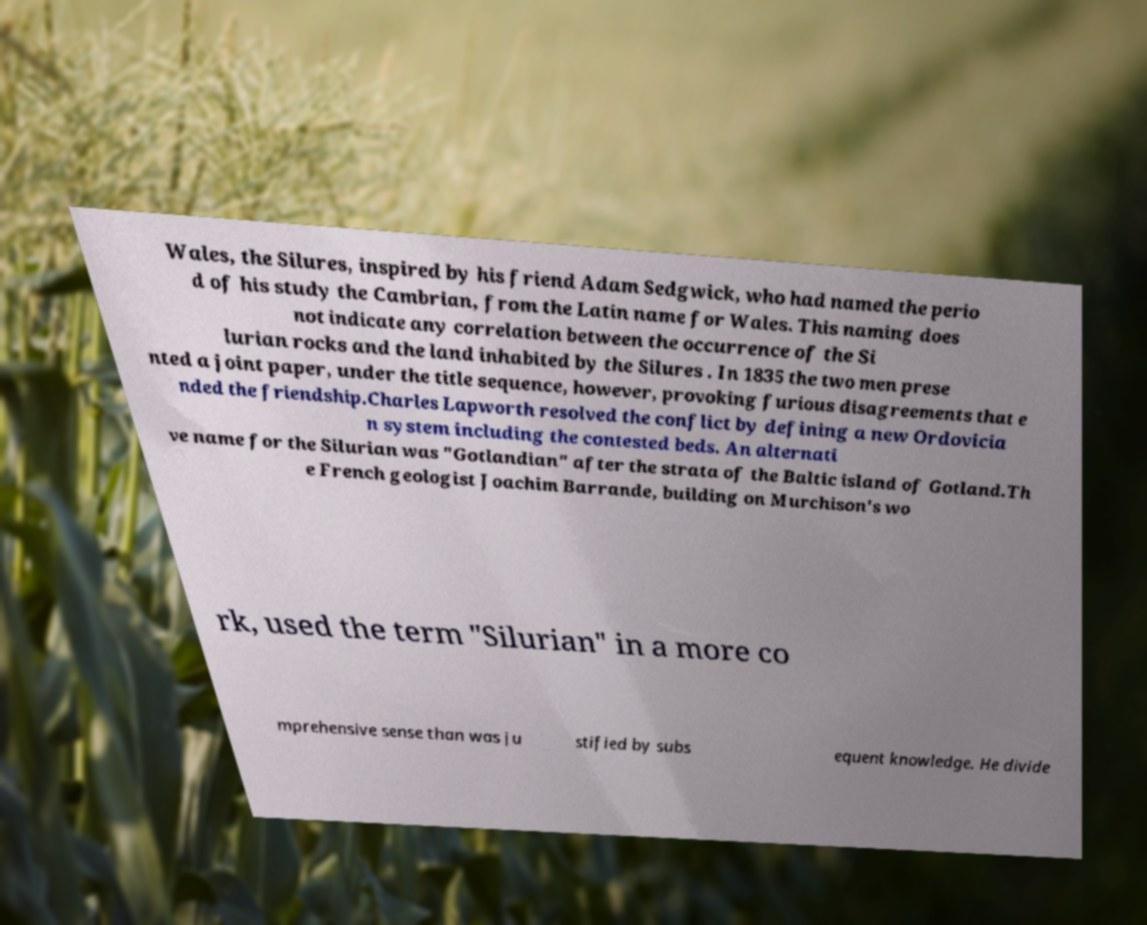Could you assist in decoding the text presented in this image and type it out clearly? Wales, the Silures, inspired by his friend Adam Sedgwick, who had named the perio d of his study the Cambrian, from the Latin name for Wales. This naming does not indicate any correlation between the occurrence of the Si lurian rocks and the land inhabited by the Silures . In 1835 the two men prese nted a joint paper, under the title sequence, however, provoking furious disagreements that e nded the friendship.Charles Lapworth resolved the conflict by defining a new Ordovicia n system including the contested beds. An alternati ve name for the Silurian was "Gotlandian" after the strata of the Baltic island of Gotland.Th e French geologist Joachim Barrande, building on Murchison's wo rk, used the term "Silurian" in a more co mprehensive sense than was ju stified by subs equent knowledge. He divide 